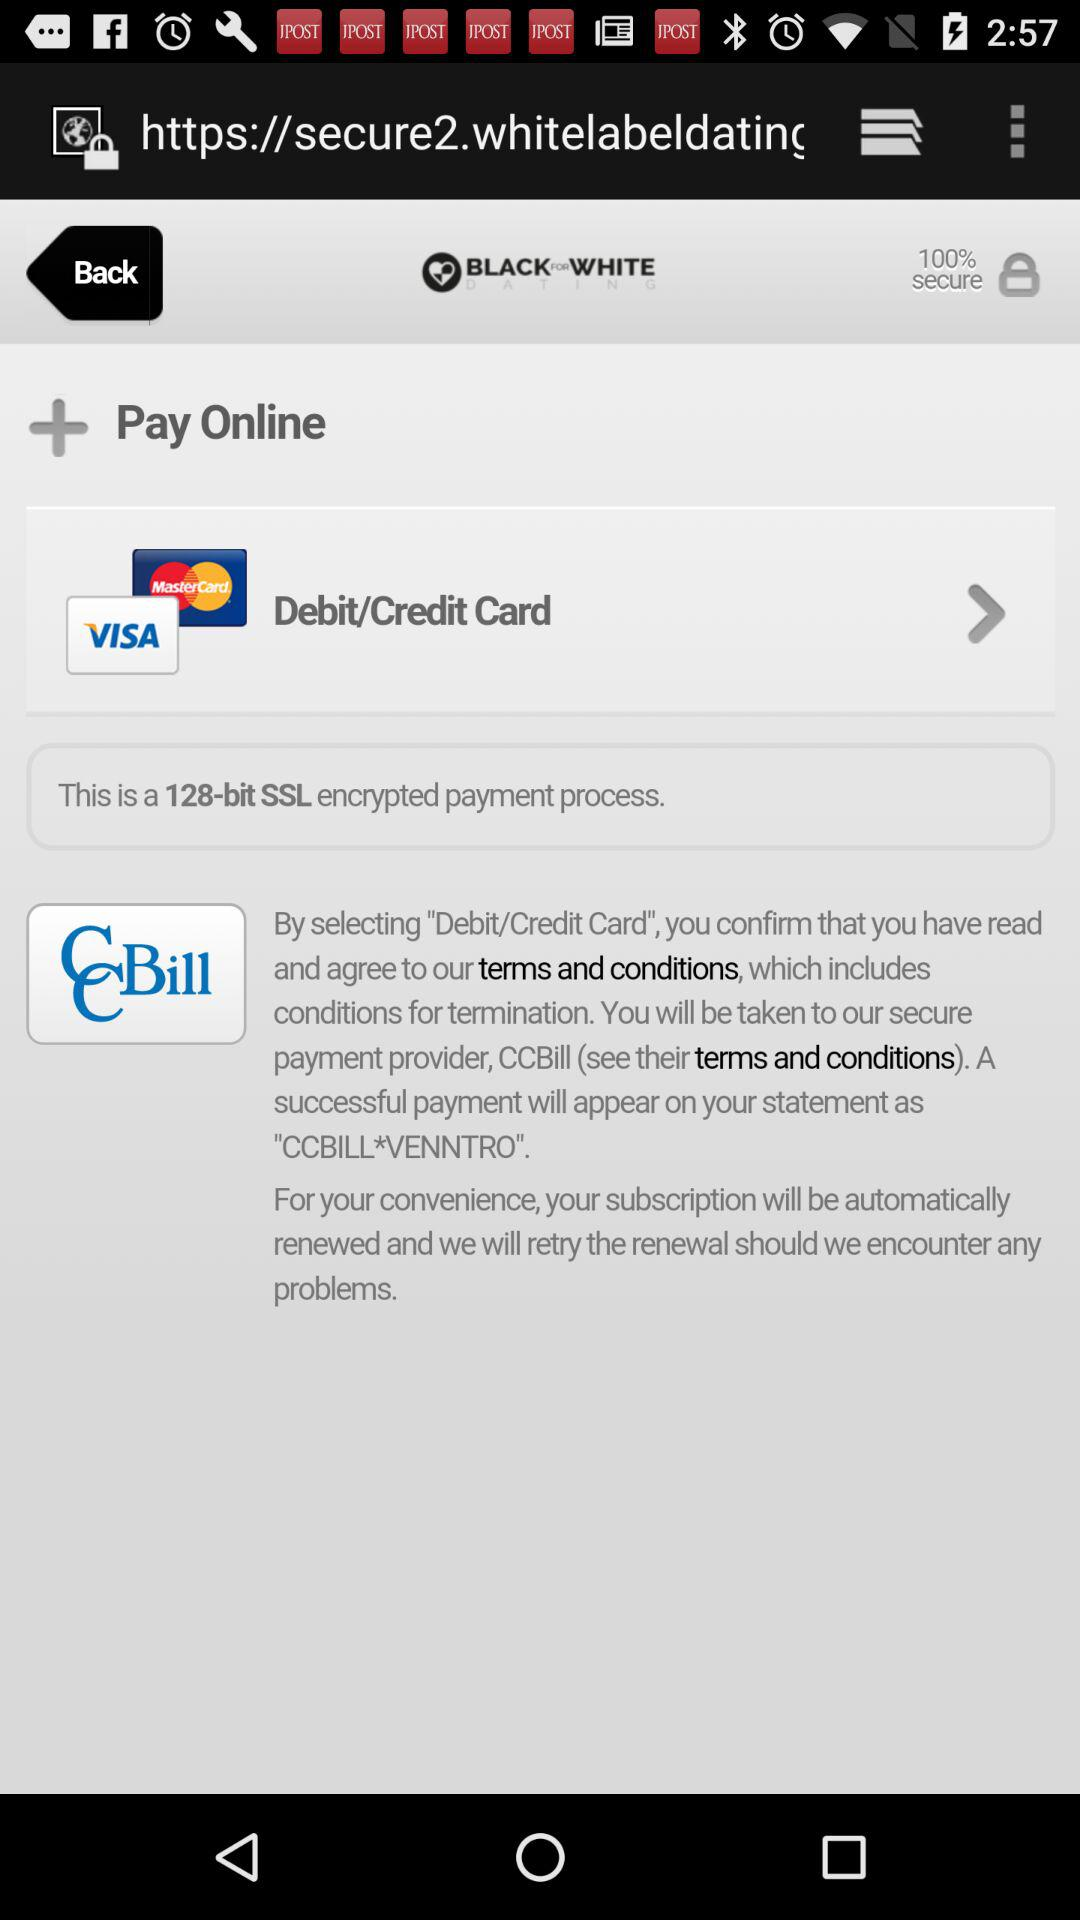How many text inputs are in the form?
Answer the question using a single word or phrase. 3 